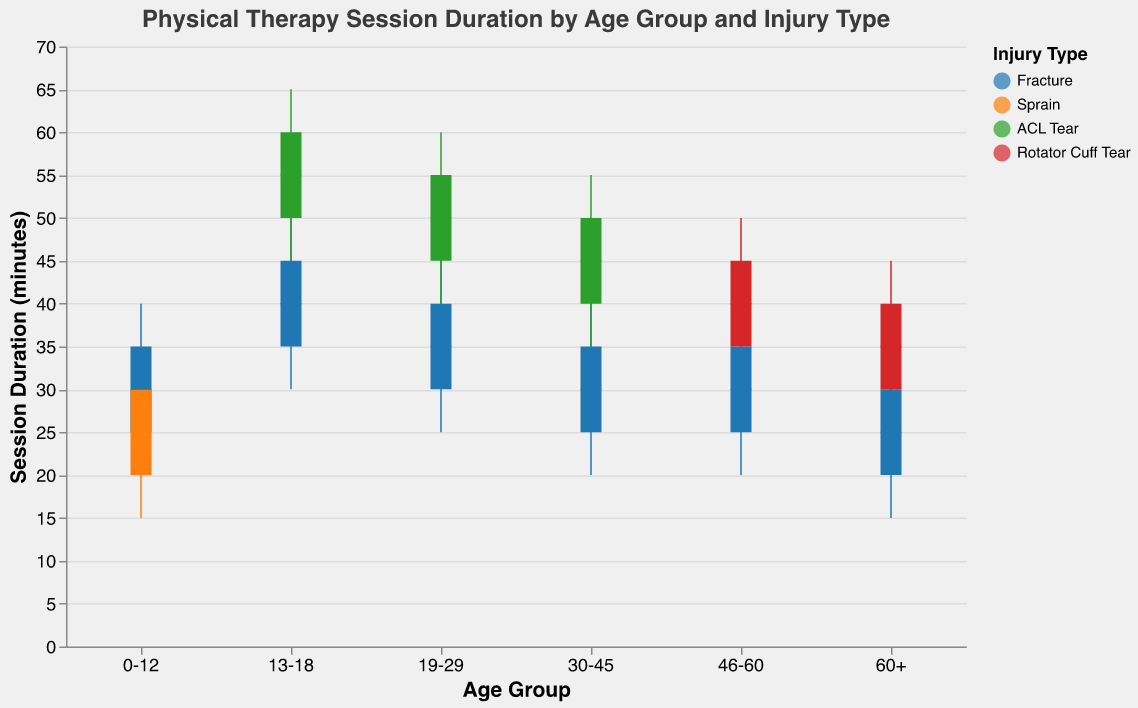Which age group has the highest median duration for ACL tear sessions? Look at the median durations for ACL tear sessions across all age groups. The age group 13-18 has a median duration of 55 minutes, which is higher than the other age groups (19-29: 50 minutes, 30-45: 45 minutes).
Answer: 13-18 What is the median duration of sessions for the age groups 0-12 with a fracture? Identify the median duration for the 0-12 age group with a fracture, which is 30 minutes.
Answer: 30 Comparing age groups 46-60 and 60+, which has a higher maximum duration for rotator cuff tear sessions? Look at the maximum durations for rotator cuff tear sessions in both age groups. The 46-60 age group has a maximum duration of 50 minutes, and the 60+ age group has a maximum duration of 45 minutes.
Answer: 46-60 What is the range of session durations for fractures in the age group 19-29? The range is the difference between the maximum and minimum values. For fractures in the 19-29 age group, the minimum duration is 25 minutes and the maximum duration is 50 minutes. The range is 50 - 25 = 25.
Answer: 25 Among all age groups with fractures, which one has the lowest minimum duration? Compare the minimum durations for fractures across all age groups. The 60+ age group with fractures has the lowest minimum duration of 15 minutes.
Answer: 60+ The 13-18 age group has how many more weekly sessions for ACL tears compared to fractures? The 13-18 age group has 4 sessions per week for ACL tears and 3 sessions per week for fractures. The difference is 4 - 3 = 1.
Answer: 1 How does the median session duration for a sprain compare to a fracture in age group 0-12? The median duration is 25 minutes for a sprain and 30 minutes for a fracture in the 0-12 age group.
Answer: Fracture is 5 minutes longer For the age group 19-29, what is the combined median duration of sessions for fractures and ACL tears? Add the median durations for fractures and ACL tears in the 19-29 age group. The median for fractures is 35 minutes, and for ACL tears, it's 50 minutes. The combined median is 35 + 50 = 85.
Answer: 85 Which injury type in the age group 30-45 has the shorter session duration range? The range is the difference between the maximum and minimum values. For fractures, the range is 45 - 20 = 25 minutes. For ACL tears, the range is 55 - 35 = 20 minutes. The ACL tear range is shorter.
Answer: ACL tear What is the lower quartile (Q1) for session durations of rotator cuff tears in the age group 60+? Identify the Q1 duration for rotator cuff tears in the 60+ age group, which is 30 minutes.
Answer: 30 